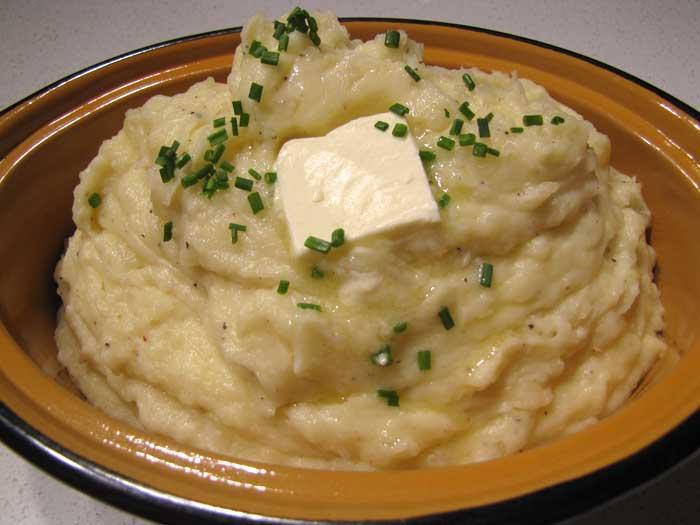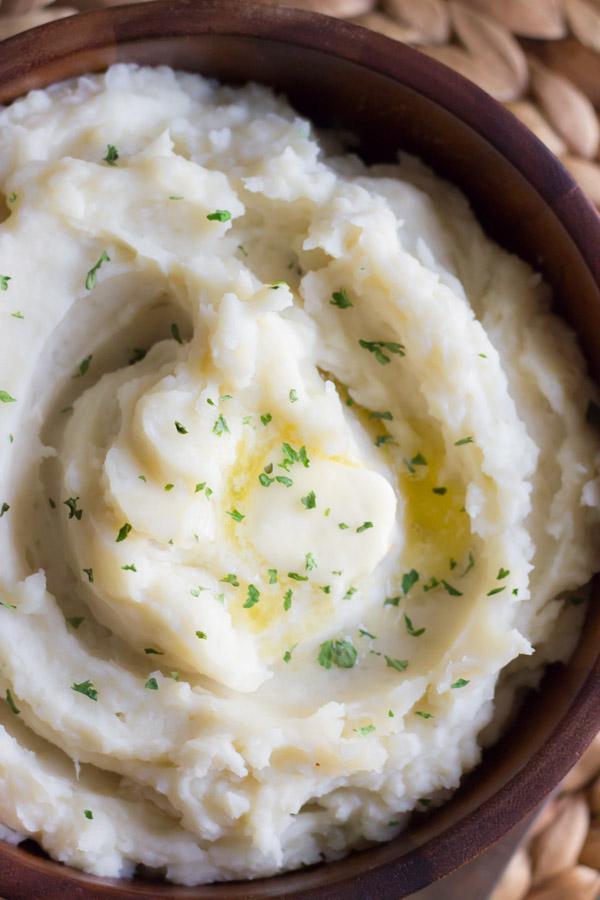The first image is the image on the left, the second image is the image on the right. Examine the images to the left and right. Is the description "Cloves of garlic are above one of the bowls of mashed potatoes." accurate? Answer yes or no. No. The first image is the image on the left, the second image is the image on the right. Analyze the images presented: Is the assertion "The left image shows finely chopped green herbs sprinkled across the top of the mashed potatoes." valid? Answer yes or no. Yes. 